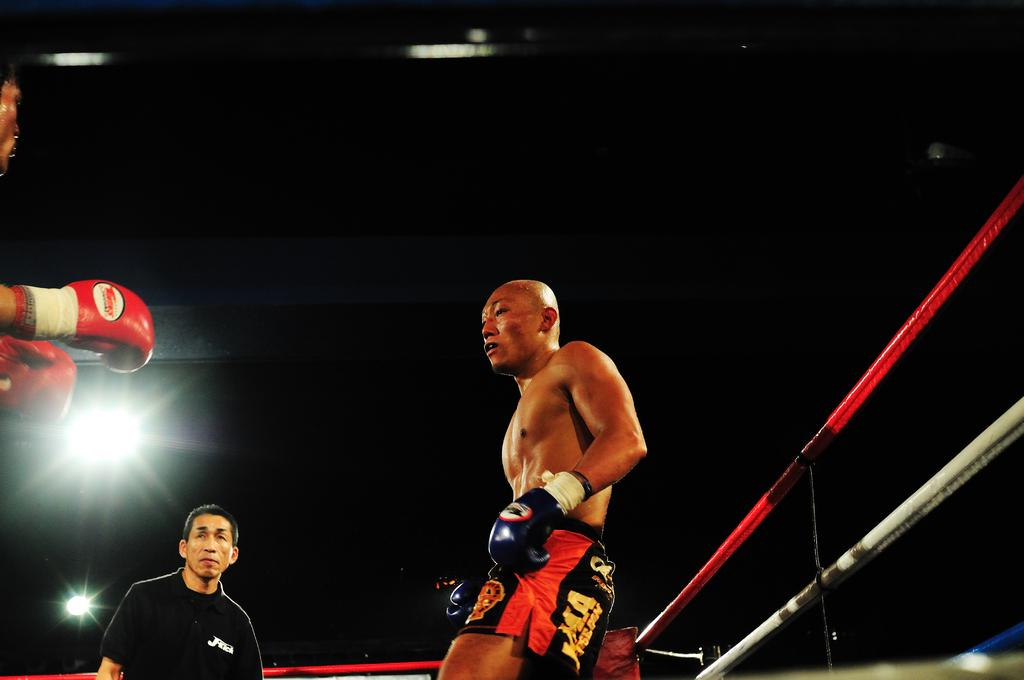<image>
Provide a brief description of the given image. A referee stands between two boxers, one has the letters M.A printed on his trunks. 